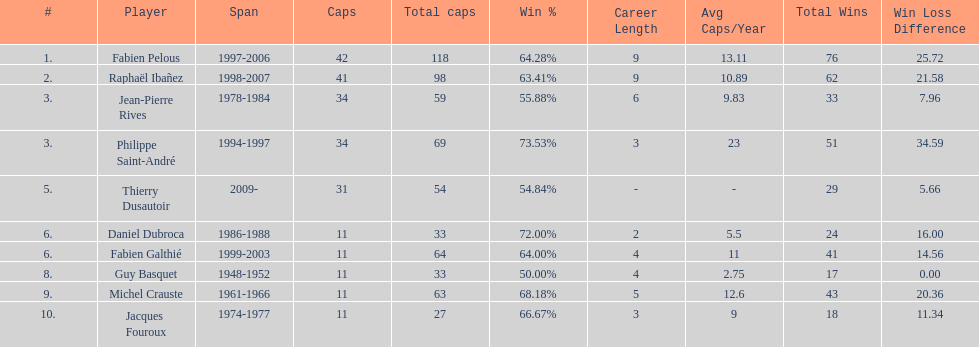How long did fabien pelous serve as captain in the french national rugby team? 9 years. 